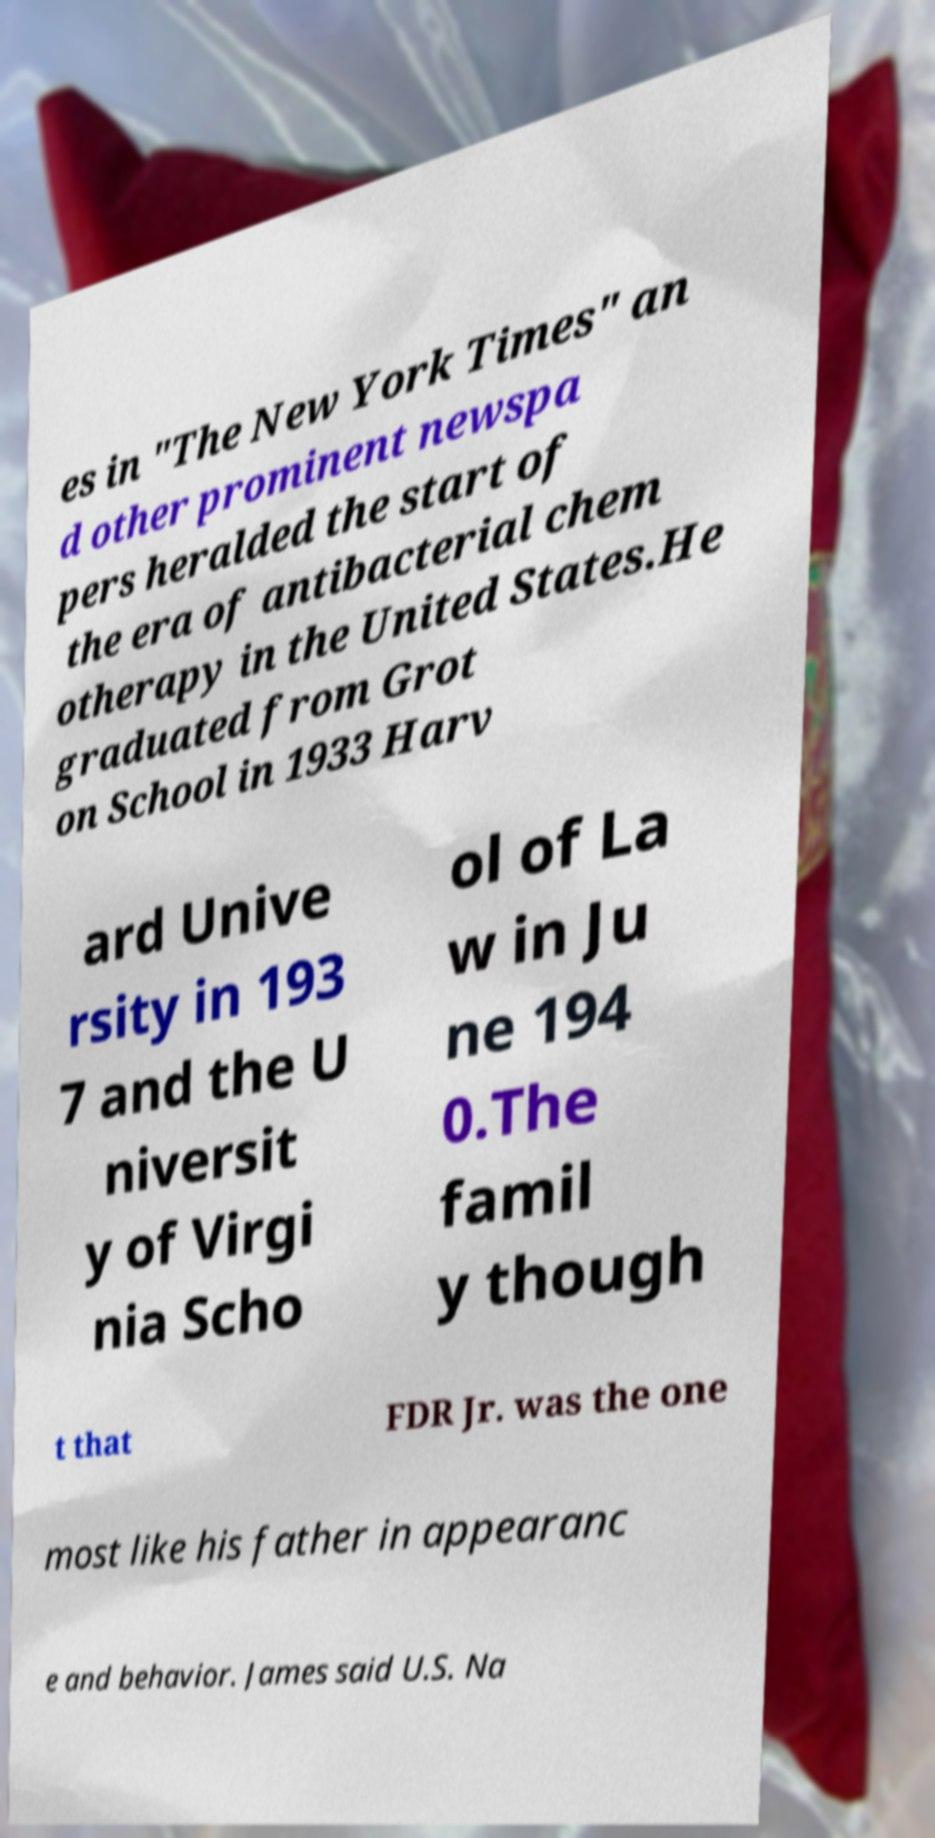Please read and relay the text visible in this image. What does it say? es in "The New York Times" an d other prominent newspa pers heralded the start of the era of antibacterial chem otherapy in the United States.He graduated from Grot on School in 1933 Harv ard Unive rsity in 193 7 and the U niversit y of Virgi nia Scho ol of La w in Ju ne 194 0.The famil y though t that FDR Jr. was the one most like his father in appearanc e and behavior. James said U.S. Na 